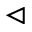<formula> <loc_0><loc_0><loc_500><loc_500>\vartriangleleft</formula> 